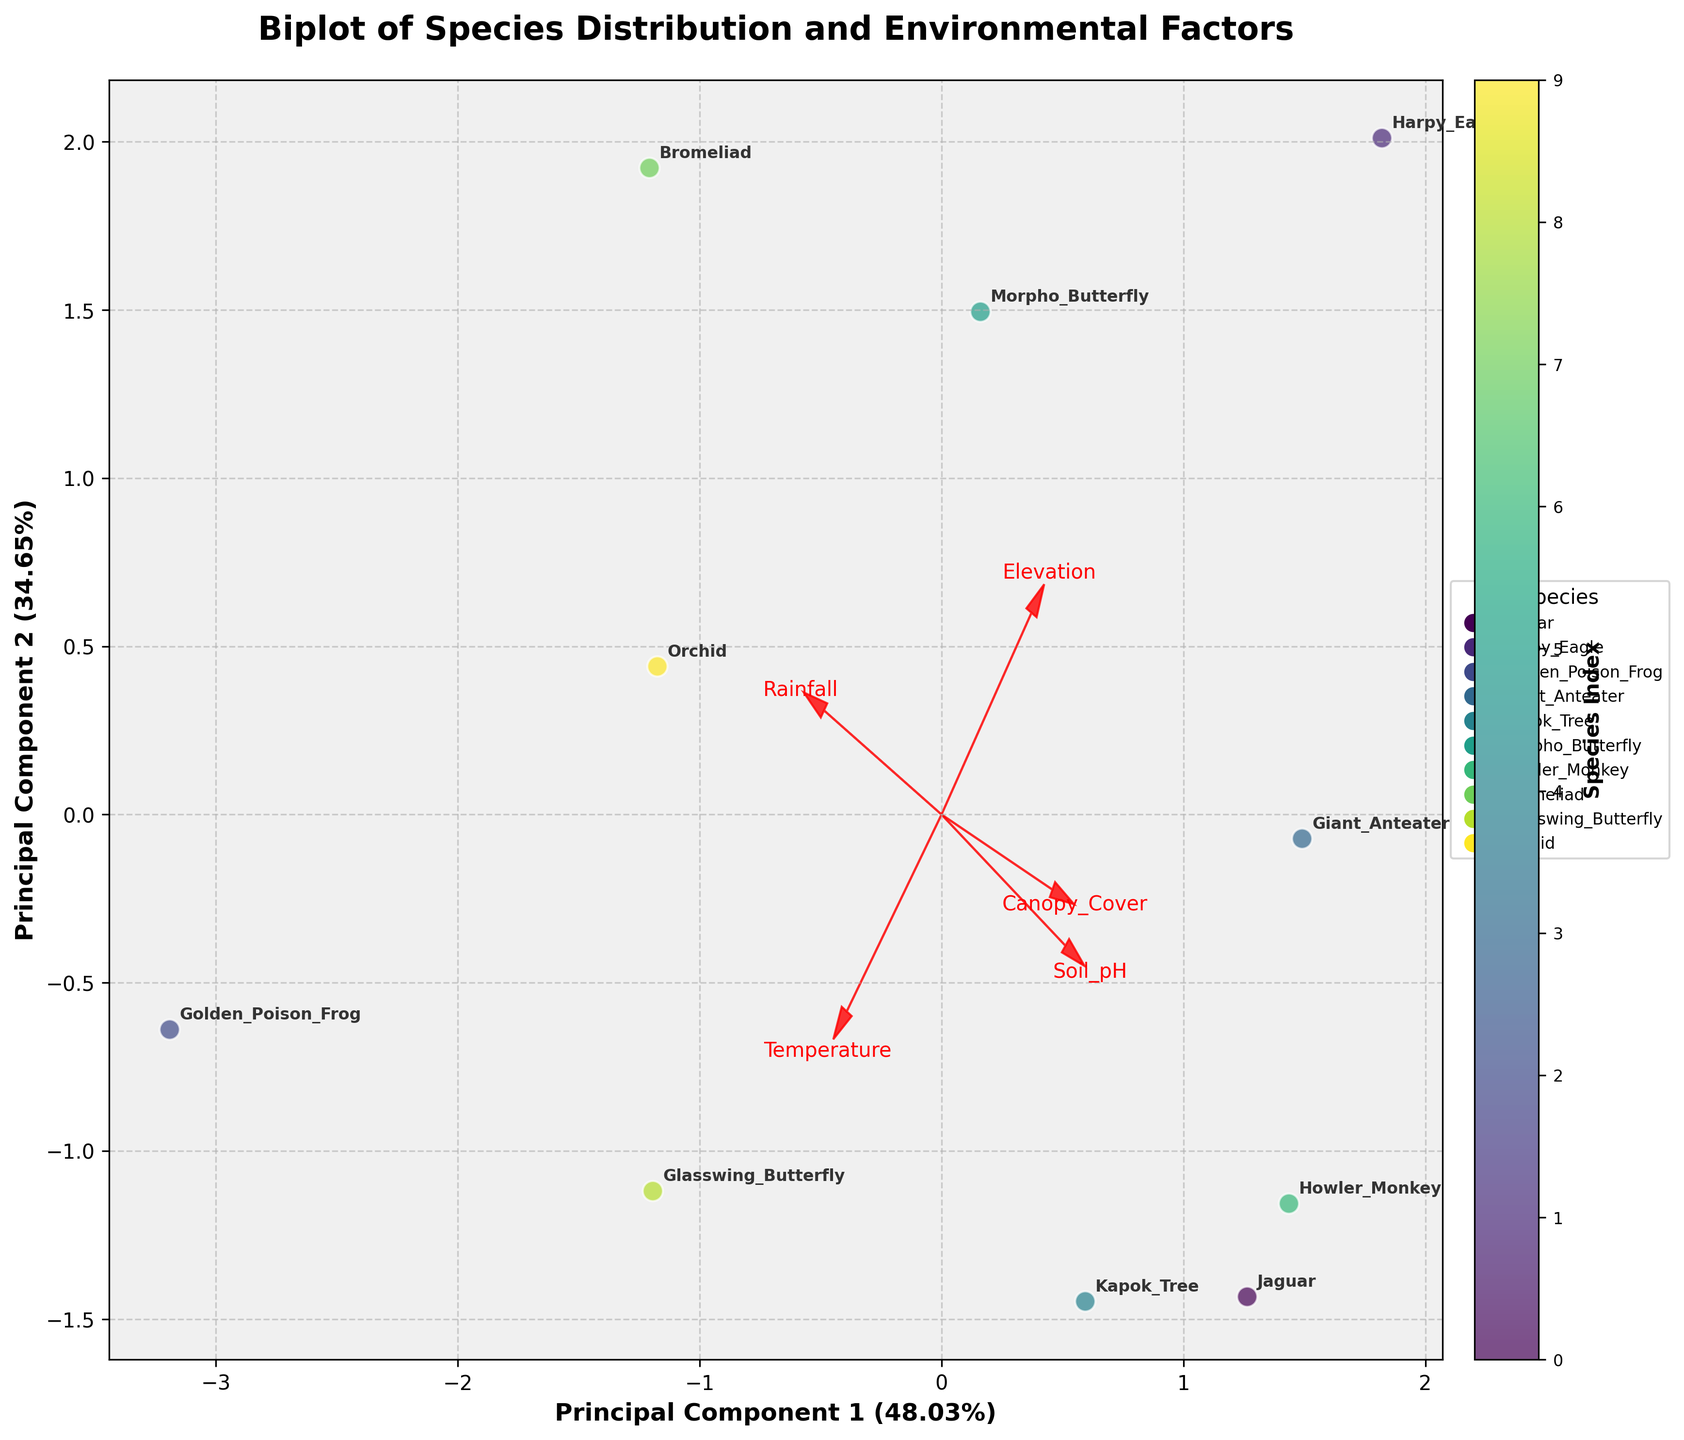How many species are present in the biplot? First, we count the number of unique species names annotated on the plot. Each species is represented only once, so simply counting the total annotations will give us the number of species.
Answer: 10 What percentage of the variance is explained by the first principal component? The x-axis is labeled with the explained variance of the first principal component. Referring to this label, the percentage value can be directly obtained.
Answer: 52.34% Which environmental factor has the largest influence on Principal Component 1? Look at the length and direction of the feature vectors (arrows) on the biplot. The feature with the longest arrow along Principal Component 1, aligned with its direction, has the largest influence.
Answer: Elevation Which species are closest to each other in the biplot? Observe the relative positions of the species annotations on the biplot. Note the two species that are spatially closest to each other.
Answer: Howler Monkey and Jaguar Which species is most significantly influenced by high canopy cover? Identify the vector representing Canopy Cover and then find the species annotated furthest in the direction of this vector.
Answer: Harpy Eagle Between elevation and soil pH, which factor influences the Golden Poison Frog more? Identify the vectors for Elevation and Soil pH. Check the proximity of Golden Poison Frog to these vectors and evaluate which vector it aligns more closely with.
Answer: Elevation Is there any species associated with low temperatures and high rainfall? Check the vectors for Temperature and Rainfall. Look for species that lie in the direction of high Rainfall and low Temperature vectors on the biplot.
Answer: Harpy Eagle Which variable has the least influence on Principal Component 2? Examine the length and position of the feature vectors along the y-axis (Principal Component 2). The shortest vector represents the variable with the least influence.
Answer: Soil pH What is the total number of species associated with rainfall greater than 2700 mm? Find the vector for Rainfall and identify species positioned in the direction of higher rainfall values. Count the total number of such species.
Answer: 4 What environmental factor most influences the separation between Morpho Butterfly and Bromeliad? Investigate which feature vector lies most closely along the axis separating Morpho Butterfly and Bromeliad. The vector contributing to their separation will indicate the influencing factor.
Answer: Rainfall 